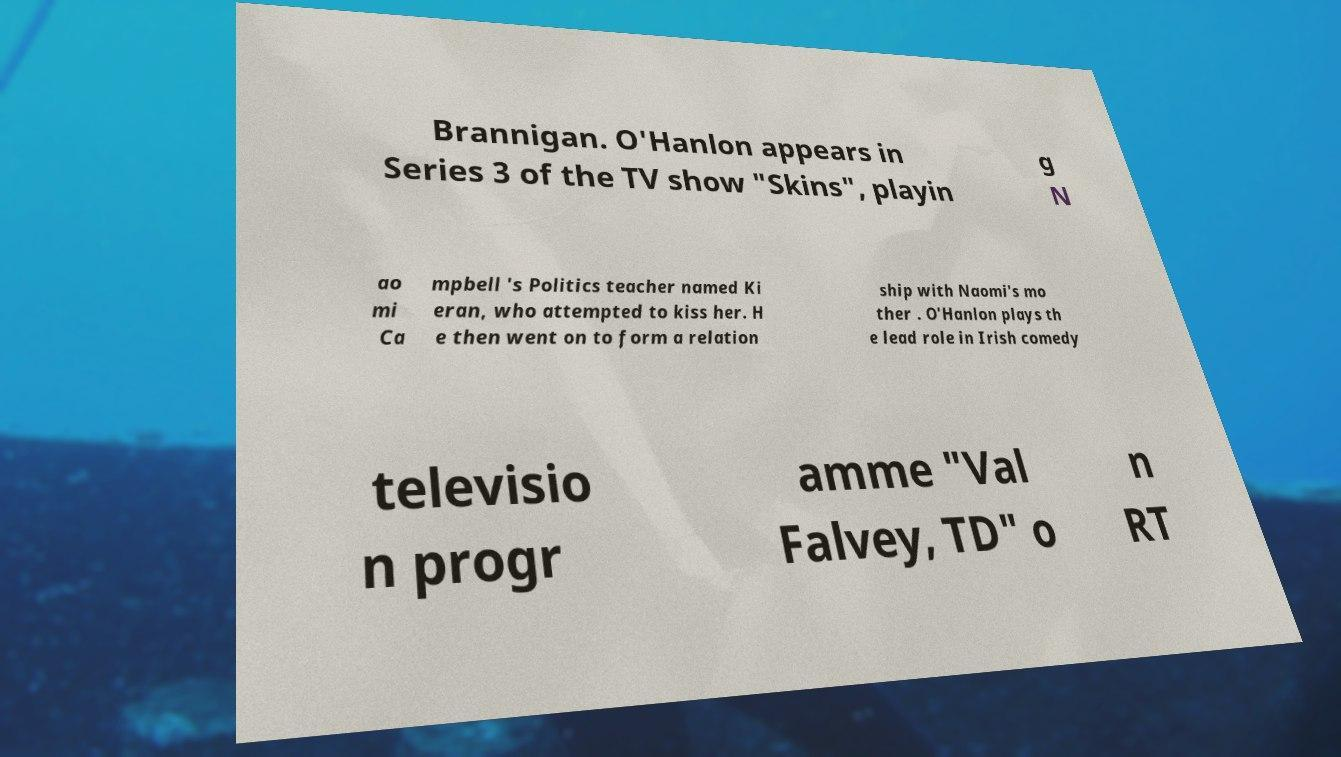Could you assist in decoding the text presented in this image and type it out clearly? Brannigan. O'Hanlon appears in Series 3 of the TV show "Skins", playin g N ao mi Ca mpbell 's Politics teacher named Ki eran, who attempted to kiss her. H e then went on to form a relation ship with Naomi's mo ther . O'Hanlon plays th e lead role in Irish comedy televisio n progr amme "Val Falvey, TD" o n RT 